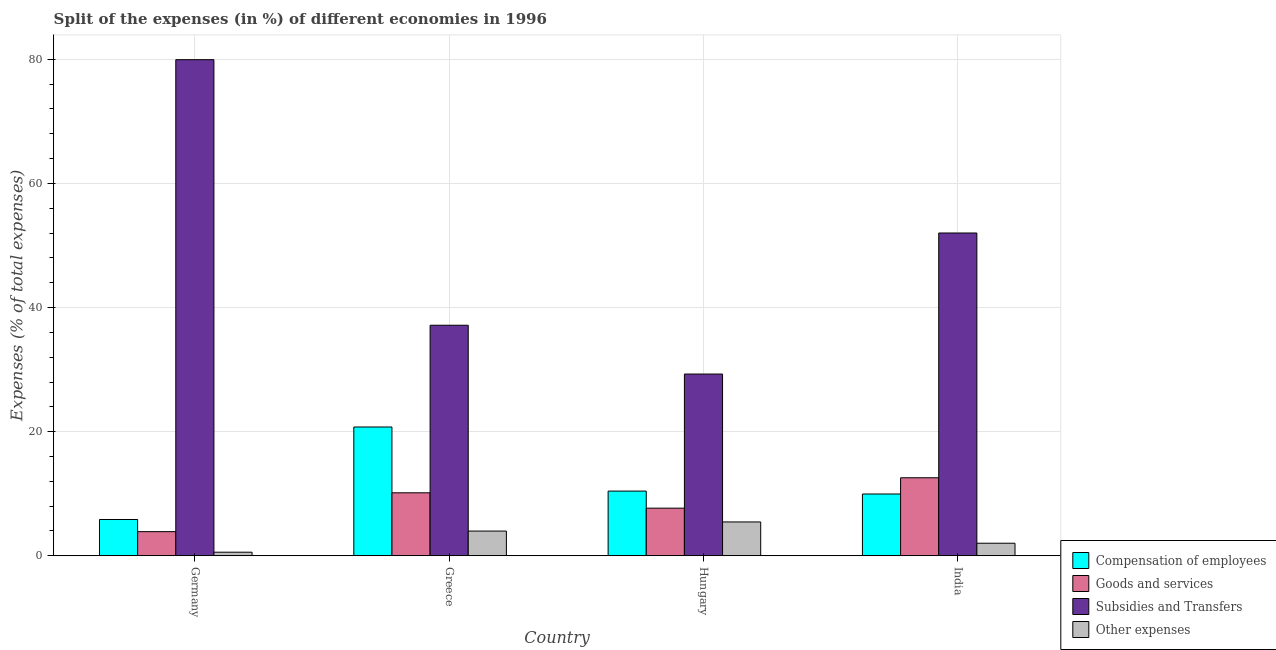Are the number of bars on each tick of the X-axis equal?
Give a very brief answer. Yes. How many bars are there on the 1st tick from the left?
Your response must be concise. 4. What is the label of the 1st group of bars from the left?
Make the answer very short. Germany. In how many cases, is the number of bars for a given country not equal to the number of legend labels?
Give a very brief answer. 0. What is the percentage of amount spent on goods and services in Greece?
Offer a very short reply. 10.15. Across all countries, what is the maximum percentage of amount spent on goods and services?
Offer a terse response. 12.57. Across all countries, what is the minimum percentage of amount spent on other expenses?
Provide a short and direct response. 0.58. In which country was the percentage of amount spent on goods and services minimum?
Provide a succinct answer. Germany. What is the total percentage of amount spent on goods and services in the graph?
Offer a very short reply. 34.28. What is the difference between the percentage of amount spent on subsidies in Germany and that in Greece?
Your answer should be compact. 42.79. What is the difference between the percentage of amount spent on goods and services in Germany and the percentage of amount spent on subsidies in Greece?
Provide a succinct answer. -33.26. What is the average percentage of amount spent on goods and services per country?
Your answer should be very brief. 8.57. What is the difference between the percentage of amount spent on goods and services and percentage of amount spent on subsidies in Germany?
Keep it short and to the point. -76.04. In how many countries, is the percentage of amount spent on subsidies greater than 48 %?
Offer a very short reply. 2. What is the ratio of the percentage of amount spent on subsidies in Greece to that in India?
Your response must be concise. 0.71. What is the difference between the highest and the second highest percentage of amount spent on compensation of employees?
Make the answer very short. 10.33. What is the difference between the highest and the lowest percentage of amount spent on compensation of employees?
Offer a terse response. 14.9. In how many countries, is the percentage of amount spent on other expenses greater than the average percentage of amount spent on other expenses taken over all countries?
Your response must be concise. 2. What does the 1st bar from the left in Greece represents?
Your answer should be very brief. Compensation of employees. What does the 4th bar from the right in India represents?
Give a very brief answer. Compensation of employees. How many bars are there?
Provide a short and direct response. 16. Are all the bars in the graph horizontal?
Ensure brevity in your answer.  No. What is the difference between two consecutive major ticks on the Y-axis?
Your response must be concise. 20. Are the values on the major ticks of Y-axis written in scientific E-notation?
Your answer should be compact. No. Does the graph contain grids?
Give a very brief answer. Yes. Where does the legend appear in the graph?
Provide a short and direct response. Bottom right. How many legend labels are there?
Your response must be concise. 4. What is the title of the graph?
Offer a terse response. Split of the expenses (in %) of different economies in 1996. Does "United Kingdom" appear as one of the legend labels in the graph?
Provide a succinct answer. No. What is the label or title of the Y-axis?
Give a very brief answer. Expenses (% of total expenses). What is the Expenses (% of total expenses) in Compensation of employees in Germany?
Keep it short and to the point. 5.85. What is the Expenses (% of total expenses) in Goods and services in Germany?
Ensure brevity in your answer.  3.89. What is the Expenses (% of total expenses) in Subsidies and Transfers in Germany?
Offer a terse response. 79.93. What is the Expenses (% of total expenses) of Other expenses in Germany?
Provide a succinct answer. 0.58. What is the Expenses (% of total expenses) in Compensation of employees in Greece?
Keep it short and to the point. 20.75. What is the Expenses (% of total expenses) in Goods and services in Greece?
Provide a succinct answer. 10.15. What is the Expenses (% of total expenses) in Subsidies and Transfers in Greece?
Keep it short and to the point. 37.15. What is the Expenses (% of total expenses) of Other expenses in Greece?
Give a very brief answer. 3.98. What is the Expenses (% of total expenses) in Compensation of employees in Hungary?
Your answer should be compact. 10.43. What is the Expenses (% of total expenses) in Goods and services in Hungary?
Your answer should be compact. 7.67. What is the Expenses (% of total expenses) in Subsidies and Transfers in Hungary?
Make the answer very short. 29.28. What is the Expenses (% of total expenses) in Other expenses in Hungary?
Your answer should be compact. 5.45. What is the Expenses (% of total expenses) in Compensation of employees in India?
Provide a short and direct response. 9.95. What is the Expenses (% of total expenses) in Goods and services in India?
Provide a succinct answer. 12.57. What is the Expenses (% of total expenses) in Subsidies and Transfers in India?
Offer a very short reply. 52.01. What is the Expenses (% of total expenses) in Other expenses in India?
Your answer should be compact. 2.03. Across all countries, what is the maximum Expenses (% of total expenses) in Compensation of employees?
Make the answer very short. 20.75. Across all countries, what is the maximum Expenses (% of total expenses) in Goods and services?
Keep it short and to the point. 12.57. Across all countries, what is the maximum Expenses (% of total expenses) in Subsidies and Transfers?
Your answer should be very brief. 79.93. Across all countries, what is the maximum Expenses (% of total expenses) in Other expenses?
Provide a short and direct response. 5.45. Across all countries, what is the minimum Expenses (% of total expenses) of Compensation of employees?
Keep it short and to the point. 5.85. Across all countries, what is the minimum Expenses (% of total expenses) of Goods and services?
Make the answer very short. 3.89. Across all countries, what is the minimum Expenses (% of total expenses) in Subsidies and Transfers?
Give a very brief answer. 29.28. Across all countries, what is the minimum Expenses (% of total expenses) of Other expenses?
Offer a very short reply. 0.58. What is the total Expenses (% of total expenses) in Compensation of employees in the graph?
Offer a very short reply. 46.98. What is the total Expenses (% of total expenses) of Goods and services in the graph?
Keep it short and to the point. 34.28. What is the total Expenses (% of total expenses) in Subsidies and Transfers in the graph?
Offer a very short reply. 198.37. What is the total Expenses (% of total expenses) of Other expenses in the graph?
Make the answer very short. 12.04. What is the difference between the Expenses (% of total expenses) of Compensation of employees in Germany and that in Greece?
Your response must be concise. -14.9. What is the difference between the Expenses (% of total expenses) in Goods and services in Germany and that in Greece?
Offer a terse response. -6.26. What is the difference between the Expenses (% of total expenses) of Subsidies and Transfers in Germany and that in Greece?
Offer a very short reply. 42.79. What is the difference between the Expenses (% of total expenses) of Other expenses in Germany and that in Greece?
Your answer should be compact. -3.4. What is the difference between the Expenses (% of total expenses) in Compensation of employees in Germany and that in Hungary?
Offer a very short reply. -4.58. What is the difference between the Expenses (% of total expenses) of Goods and services in Germany and that in Hungary?
Ensure brevity in your answer.  -3.78. What is the difference between the Expenses (% of total expenses) in Subsidies and Transfers in Germany and that in Hungary?
Your response must be concise. 50.65. What is the difference between the Expenses (% of total expenses) of Other expenses in Germany and that in Hungary?
Your response must be concise. -4.87. What is the difference between the Expenses (% of total expenses) of Compensation of employees in Germany and that in India?
Your response must be concise. -4.11. What is the difference between the Expenses (% of total expenses) in Goods and services in Germany and that in India?
Offer a terse response. -8.68. What is the difference between the Expenses (% of total expenses) in Subsidies and Transfers in Germany and that in India?
Offer a terse response. 27.92. What is the difference between the Expenses (% of total expenses) in Other expenses in Germany and that in India?
Give a very brief answer. -1.45. What is the difference between the Expenses (% of total expenses) of Compensation of employees in Greece and that in Hungary?
Offer a very short reply. 10.33. What is the difference between the Expenses (% of total expenses) in Goods and services in Greece and that in Hungary?
Give a very brief answer. 2.48. What is the difference between the Expenses (% of total expenses) in Subsidies and Transfers in Greece and that in Hungary?
Ensure brevity in your answer.  7.86. What is the difference between the Expenses (% of total expenses) of Other expenses in Greece and that in Hungary?
Your answer should be compact. -1.47. What is the difference between the Expenses (% of total expenses) of Compensation of employees in Greece and that in India?
Your answer should be very brief. 10.8. What is the difference between the Expenses (% of total expenses) of Goods and services in Greece and that in India?
Provide a short and direct response. -2.42. What is the difference between the Expenses (% of total expenses) of Subsidies and Transfers in Greece and that in India?
Keep it short and to the point. -14.86. What is the difference between the Expenses (% of total expenses) of Other expenses in Greece and that in India?
Give a very brief answer. 1.96. What is the difference between the Expenses (% of total expenses) in Compensation of employees in Hungary and that in India?
Offer a very short reply. 0.47. What is the difference between the Expenses (% of total expenses) in Goods and services in Hungary and that in India?
Offer a very short reply. -4.9. What is the difference between the Expenses (% of total expenses) in Subsidies and Transfers in Hungary and that in India?
Offer a very short reply. -22.72. What is the difference between the Expenses (% of total expenses) in Other expenses in Hungary and that in India?
Keep it short and to the point. 3.43. What is the difference between the Expenses (% of total expenses) of Compensation of employees in Germany and the Expenses (% of total expenses) of Goods and services in Greece?
Give a very brief answer. -4.3. What is the difference between the Expenses (% of total expenses) in Compensation of employees in Germany and the Expenses (% of total expenses) in Subsidies and Transfers in Greece?
Ensure brevity in your answer.  -31.3. What is the difference between the Expenses (% of total expenses) of Compensation of employees in Germany and the Expenses (% of total expenses) of Other expenses in Greece?
Offer a terse response. 1.87. What is the difference between the Expenses (% of total expenses) of Goods and services in Germany and the Expenses (% of total expenses) of Subsidies and Transfers in Greece?
Your answer should be compact. -33.26. What is the difference between the Expenses (% of total expenses) in Goods and services in Germany and the Expenses (% of total expenses) in Other expenses in Greece?
Offer a very short reply. -0.09. What is the difference between the Expenses (% of total expenses) of Subsidies and Transfers in Germany and the Expenses (% of total expenses) of Other expenses in Greece?
Your answer should be very brief. 75.95. What is the difference between the Expenses (% of total expenses) in Compensation of employees in Germany and the Expenses (% of total expenses) in Goods and services in Hungary?
Keep it short and to the point. -1.82. What is the difference between the Expenses (% of total expenses) in Compensation of employees in Germany and the Expenses (% of total expenses) in Subsidies and Transfers in Hungary?
Offer a terse response. -23.44. What is the difference between the Expenses (% of total expenses) in Compensation of employees in Germany and the Expenses (% of total expenses) in Other expenses in Hungary?
Offer a terse response. 0.39. What is the difference between the Expenses (% of total expenses) in Goods and services in Germany and the Expenses (% of total expenses) in Subsidies and Transfers in Hungary?
Offer a very short reply. -25.39. What is the difference between the Expenses (% of total expenses) of Goods and services in Germany and the Expenses (% of total expenses) of Other expenses in Hungary?
Your answer should be very brief. -1.56. What is the difference between the Expenses (% of total expenses) in Subsidies and Transfers in Germany and the Expenses (% of total expenses) in Other expenses in Hungary?
Your answer should be compact. 74.48. What is the difference between the Expenses (% of total expenses) of Compensation of employees in Germany and the Expenses (% of total expenses) of Goods and services in India?
Your answer should be very brief. -6.72. What is the difference between the Expenses (% of total expenses) in Compensation of employees in Germany and the Expenses (% of total expenses) in Subsidies and Transfers in India?
Make the answer very short. -46.16. What is the difference between the Expenses (% of total expenses) of Compensation of employees in Germany and the Expenses (% of total expenses) of Other expenses in India?
Ensure brevity in your answer.  3.82. What is the difference between the Expenses (% of total expenses) of Goods and services in Germany and the Expenses (% of total expenses) of Subsidies and Transfers in India?
Your response must be concise. -48.12. What is the difference between the Expenses (% of total expenses) of Goods and services in Germany and the Expenses (% of total expenses) of Other expenses in India?
Your answer should be compact. 1.87. What is the difference between the Expenses (% of total expenses) of Subsidies and Transfers in Germany and the Expenses (% of total expenses) of Other expenses in India?
Give a very brief answer. 77.91. What is the difference between the Expenses (% of total expenses) of Compensation of employees in Greece and the Expenses (% of total expenses) of Goods and services in Hungary?
Your answer should be very brief. 13.08. What is the difference between the Expenses (% of total expenses) in Compensation of employees in Greece and the Expenses (% of total expenses) in Subsidies and Transfers in Hungary?
Your answer should be very brief. -8.53. What is the difference between the Expenses (% of total expenses) in Compensation of employees in Greece and the Expenses (% of total expenses) in Other expenses in Hungary?
Keep it short and to the point. 15.3. What is the difference between the Expenses (% of total expenses) in Goods and services in Greece and the Expenses (% of total expenses) in Subsidies and Transfers in Hungary?
Provide a short and direct response. -19.14. What is the difference between the Expenses (% of total expenses) of Goods and services in Greece and the Expenses (% of total expenses) of Other expenses in Hungary?
Provide a short and direct response. 4.69. What is the difference between the Expenses (% of total expenses) in Subsidies and Transfers in Greece and the Expenses (% of total expenses) in Other expenses in Hungary?
Offer a very short reply. 31.69. What is the difference between the Expenses (% of total expenses) of Compensation of employees in Greece and the Expenses (% of total expenses) of Goods and services in India?
Your response must be concise. 8.18. What is the difference between the Expenses (% of total expenses) in Compensation of employees in Greece and the Expenses (% of total expenses) in Subsidies and Transfers in India?
Provide a succinct answer. -31.26. What is the difference between the Expenses (% of total expenses) in Compensation of employees in Greece and the Expenses (% of total expenses) in Other expenses in India?
Keep it short and to the point. 18.73. What is the difference between the Expenses (% of total expenses) in Goods and services in Greece and the Expenses (% of total expenses) in Subsidies and Transfers in India?
Offer a terse response. -41.86. What is the difference between the Expenses (% of total expenses) in Goods and services in Greece and the Expenses (% of total expenses) in Other expenses in India?
Your answer should be compact. 8.12. What is the difference between the Expenses (% of total expenses) of Subsidies and Transfers in Greece and the Expenses (% of total expenses) of Other expenses in India?
Offer a very short reply. 35.12. What is the difference between the Expenses (% of total expenses) in Compensation of employees in Hungary and the Expenses (% of total expenses) in Goods and services in India?
Ensure brevity in your answer.  -2.15. What is the difference between the Expenses (% of total expenses) of Compensation of employees in Hungary and the Expenses (% of total expenses) of Subsidies and Transfers in India?
Offer a very short reply. -41.58. What is the difference between the Expenses (% of total expenses) of Compensation of employees in Hungary and the Expenses (% of total expenses) of Other expenses in India?
Your answer should be very brief. 8.4. What is the difference between the Expenses (% of total expenses) of Goods and services in Hungary and the Expenses (% of total expenses) of Subsidies and Transfers in India?
Provide a succinct answer. -44.34. What is the difference between the Expenses (% of total expenses) of Goods and services in Hungary and the Expenses (% of total expenses) of Other expenses in India?
Offer a very short reply. 5.65. What is the difference between the Expenses (% of total expenses) in Subsidies and Transfers in Hungary and the Expenses (% of total expenses) in Other expenses in India?
Ensure brevity in your answer.  27.26. What is the average Expenses (% of total expenses) in Compensation of employees per country?
Give a very brief answer. 11.74. What is the average Expenses (% of total expenses) in Goods and services per country?
Ensure brevity in your answer.  8.57. What is the average Expenses (% of total expenses) in Subsidies and Transfers per country?
Make the answer very short. 49.59. What is the average Expenses (% of total expenses) of Other expenses per country?
Provide a succinct answer. 3.01. What is the difference between the Expenses (% of total expenses) of Compensation of employees and Expenses (% of total expenses) of Goods and services in Germany?
Ensure brevity in your answer.  1.96. What is the difference between the Expenses (% of total expenses) of Compensation of employees and Expenses (% of total expenses) of Subsidies and Transfers in Germany?
Give a very brief answer. -74.08. What is the difference between the Expenses (% of total expenses) of Compensation of employees and Expenses (% of total expenses) of Other expenses in Germany?
Your answer should be very brief. 5.27. What is the difference between the Expenses (% of total expenses) of Goods and services and Expenses (% of total expenses) of Subsidies and Transfers in Germany?
Make the answer very short. -76.04. What is the difference between the Expenses (% of total expenses) of Goods and services and Expenses (% of total expenses) of Other expenses in Germany?
Offer a terse response. 3.31. What is the difference between the Expenses (% of total expenses) of Subsidies and Transfers and Expenses (% of total expenses) of Other expenses in Germany?
Offer a very short reply. 79.35. What is the difference between the Expenses (% of total expenses) in Compensation of employees and Expenses (% of total expenses) in Goods and services in Greece?
Keep it short and to the point. 10.6. What is the difference between the Expenses (% of total expenses) of Compensation of employees and Expenses (% of total expenses) of Subsidies and Transfers in Greece?
Give a very brief answer. -16.39. What is the difference between the Expenses (% of total expenses) of Compensation of employees and Expenses (% of total expenses) of Other expenses in Greece?
Your answer should be very brief. 16.77. What is the difference between the Expenses (% of total expenses) in Goods and services and Expenses (% of total expenses) in Subsidies and Transfers in Greece?
Provide a succinct answer. -27. What is the difference between the Expenses (% of total expenses) of Goods and services and Expenses (% of total expenses) of Other expenses in Greece?
Make the answer very short. 6.17. What is the difference between the Expenses (% of total expenses) in Subsidies and Transfers and Expenses (% of total expenses) in Other expenses in Greece?
Your answer should be very brief. 33.16. What is the difference between the Expenses (% of total expenses) of Compensation of employees and Expenses (% of total expenses) of Goods and services in Hungary?
Ensure brevity in your answer.  2.75. What is the difference between the Expenses (% of total expenses) of Compensation of employees and Expenses (% of total expenses) of Subsidies and Transfers in Hungary?
Your answer should be compact. -18.86. What is the difference between the Expenses (% of total expenses) of Compensation of employees and Expenses (% of total expenses) of Other expenses in Hungary?
Ensure brevity in your answer.  4.97. What is the difference between the Expenses (% of total expenses) in Goods and services and Expenses (% of total expenses) in Subsidies and Transfers in Hungary?
Give a very brief answer. -21.61. What is the difference between the Expenses (% of total expenses) in Goods and services and Expenses (% of total expenses) in Other expenses in Hungary?
Offer a terse response. 2.22. What is the difference between the Expenses (% of total expenses) in Subsidies and Transfers and Expenses (% of total expenses) in Other expenses in Hungary?
Your answer should be very brief. 23.83. What is the difference between the Expenses (% of total expenses) in Compensation of employees and Expenses (% of total expenses) in Goods and services in India?
Offer a terse response. -2.62. What is the difference between the Expenses (% of total expenses) in Compensation of employees and Expenses (% of total expenses) in Subsidies and Transfers in India?
Offer a terse response. -42.05. What is the difference between the Expenses (% of total expenses) in Compensation of employees and Expenses (% of total expenses) in Other expenses in India?
Your answer should be compact. 7.93. What is the difference between the Expenses (% of total expenses) of Goods and services and Expenses (% of total expenses) of Subsidies and Transfers in India?
Give a very brief answer. -39.44. What is the difference between the Expenses (% of total expenses) in Goods and services and Expenses (% of total expenses) in Other expenses in India?
Make the answer very short. 10.55. What is the difference between the Expenses (% of total expenses) in Subsidies and Transfers and Expenses (% of total expenses) in Other expenses in India?
Give a very brief answer. 49.98. What is the ratio of the Expenses (% of total expenses) of Compensation of employees in Germany to that in Greece?
Ensure brevity in your answer.  0.28. What is the ratio of the Expenses (% of total expenses) in Goods and services in Germany to that in Greece?
Offer a terse response. 0.38. What is the ratio of the Expenses (% of total expenses) in Subsidies and Transfers in Germany to that in Greece?
Your answer should be very brief. 2.15. What is the ratio of the Expenses (% of total expenses) of Other expenses in Germany to that in Greece?
Provide a succinct answer. 0.15. What is the ratio of the Expenses (% of total expenses) in Compensation of employees in Germany to that in Hungary?
Offer a very short reply. 0.56. What is the ratio of the Expenses (% of total expenses) of Goods and services in Germany to that in Hungary?
Offer a very short reply. 0.51. What is the ratio of the Expenses (% of total expenses) in Subsidies and Transfers in Germany to that in Hungary?
Provide a succinct answer. 2.73. What is the ratio of the Expenses (% of total expenses) in Other expenses in Germany to that in Hungary?
Your answer should be very brief. 0.11. What is the ratio of the Expenses (% of total expenses) of Compensation of employees in Germany to that in India?
Ensure brevity in your answer.  0.59. What is the ratio of the Expenses (% of total expenses) in Goods and services in Germany to that in India?
Offer a very short reply. 0.31. What is the ratio of the Expenses (% of total expenses) of Subsidies and Transfers in Germany to that in India?
Make the answer very short. 1.54. What is the ratio of the Expenses (% of total expenses) in Other expenses in Germany to that in India?
Give a very brief answer. 0.29. What is the ratio of the Expenses (% of total expenses) of Compensation of employees in Greece to that in Hungary?
Ensure brevity in your answer.  1.99. What is the ratio of the Expenses (% of total expenses) in Goods and services in Greece to that in Hungary?
Your answer should be very brief. 1.32. What is the ratio of the Expenses (% of total expenses) in Subsidies and Transfers in Greece to that in Hungary?
Give a very brief answer. 1.27. What is the ratio of the Expenses (% of total expenses) of Other expenses in Greece to that in Hungary?
Your answer should be very brief. 0.73. What is the ratio of the Expenses (% of total expenses) of Compensation of employees in Greece to that in India?
Offer a very short reply. 2.08. What is the ratio of the Expenses (% of total expenses) in Goods and services in Greece to that in India?
Offer a terse response. 0.81. What is the ratio of the Expenses (% of total expenses) of Subsidies and Transfers in Greece to that in India?
Provide a succinct answer. 0.71. What is the ratio of the Expenses (% of total expenses) of Other expenses in Greece to that in India?
Your answer should be very brief. 1.97. What is the ratio of the Expenses (% of total expenses) of Compensation of employees in Hungary to that in India?
Your answer should be very brief. 1.05. What is the ratio of the Expenses (% of total expenses) in Goods and services in Hungary to that in India?
Offer a very short reply. 0.61. What is the ratio of the Expenses (% of total expenses) of Subsidies and Transfers in Hungary to that in India?
Your response must be concise. 0.56. What is the ratio of the Expenses (% of total expenses) in Other expenses in Hungary to that in India?
Your answer should be compact. 2.69. What is the difference between the highest and the second highest Expenses (% of total expenses) in Compensation of employees?
Offer a terse response. 10.33. What is the difference between the highest and the second highest Expenses (% of total expenses) of Goods and services?
Provide a succinct answer. 2.42. What is the difference between the highest and the second highest Expenses (% of total expenses) of Subsidies and Transfers?
Provide a succinct answer. 27.92. What is the difference between the highest and the second highest Expenses (% of total expenses) in Other expenses?
Provide a short and direct response. 1.47. What is the difference between the highest and the lowest Expenses (% of total expenses) in Compensation of employees?
Offer a terse response. 14.9. What is the difference between the highest and the lowest Expenses (% of total expenses) in Goods and services?
Provide a short and direct response. 8.68. What is the difference between the highest and the lowest Expenses (% of total expenses) in Subsidies and Transfers?
Your answer should be compact. 50.65. What is the difference between the highest and the lowest Expenses (% of total expenses) in Other expenses?
Make the answer very short. 4.87. 